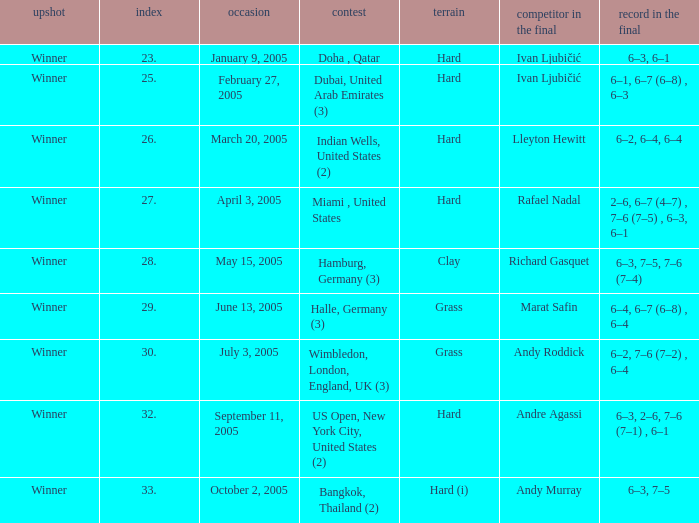How many championships are there on the date January 9, 2005? 1.0. 